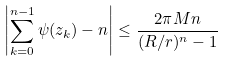Convert formula to latex. <formula><loc_0><loc_0><loc_500><loc_500>\left | \sum _ { k = 0 } ^ { n - 1 } \psi ( z _ { k } ) - n \right | \leq \frac { 2 \pi M n } { ( R / r ) ^ { n } - 1 }</formula> 